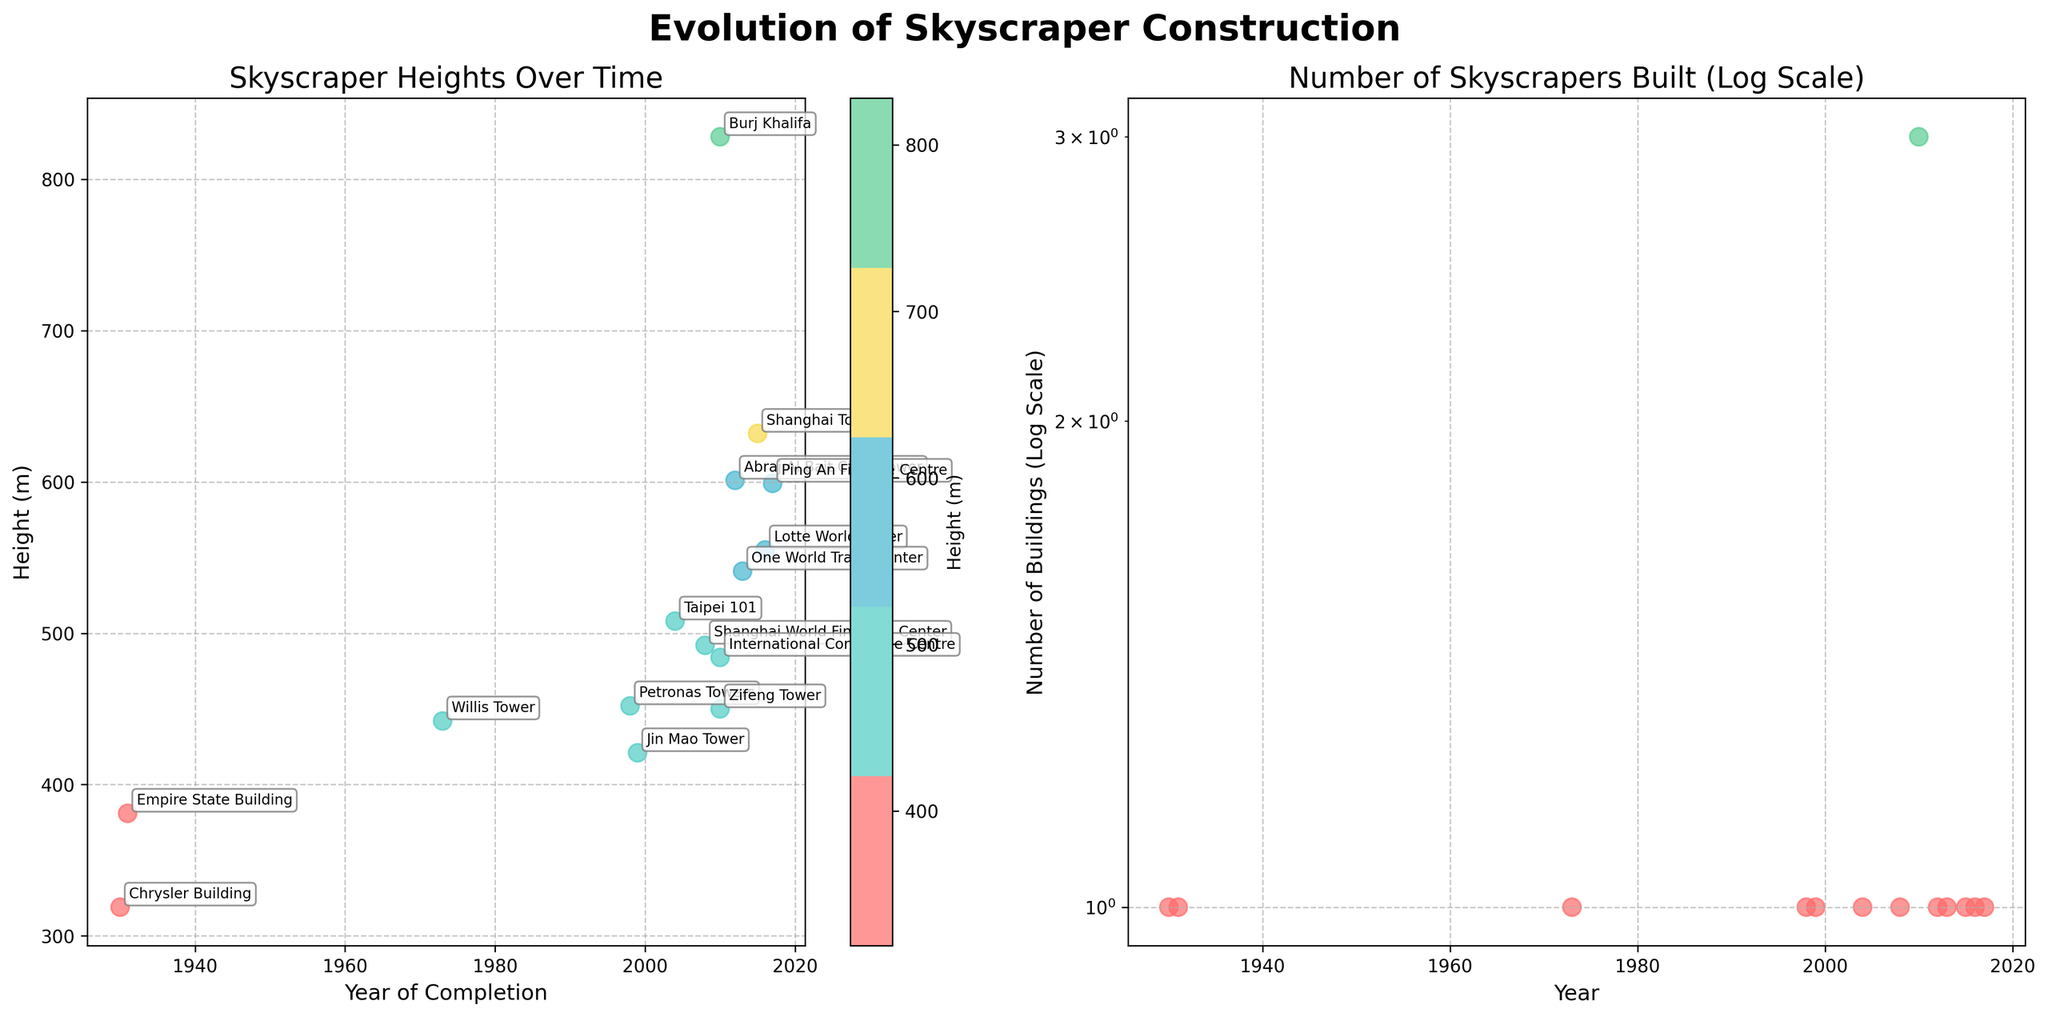What is the title of the figure? The title of the figure is usually found at the top center. In this case, it is "Evolution of Skyscraper Construction".
Answer: Evolution of Skyscraper Construction What is the x-axis label for the plot on the left? The x-axis label for the plot on the left can be found below the x-axis. Here, the label is "Year of Completion".
Answer: Year of Completion How many buildings were completed between 2000 and 2010 inclusive, according to the right subplot? To answer this, we count the number of skyscrapers completed between 2000 and 2010 inclusive. From the data: Taipei 101 (2004), Shanghai World Financial Center (2008), International Commerce Centre (2010), Burj Khalifa (2010), Zifeng Tower (2010) which totals to 5.
Answer: 5 What is the total height of skyscrapers completed in 2010 as shown in the left subplot? To find this, sum the heights of skyscrapers completed in 2010, which are Burj Khalifa (828m), International Commerce Centre (484m), and Zifeng Tower (450m). The total is 828 + 484 + 450 = 1762m.
Answer: 1762m Which building is the tallest according to the left subplot and in which year was it completed? The tallest building can be identified by looking at the highest point on the y-axis. The tallest from the list is Burj Khalifa at 828 meters, completed in 2010.
Answer: Burj Khalifa, 2010 Is there a year where more than one skyscraper was completed according to the right subplot? By inspecting the scatter plot for overlapping points on the x-axis, we see that 2010 has multiple points, indicating more than one skyscraper was completed in that year.
Answer: Yes, 2010 Which year has the highest number of skyscraper completions on a logarithmic scale, as illustrated on the right subplot? To find this, look for the data point with the highest value on the y-axis of the right subplot. The year 2010 has the highest number of completions.
Answer: 2010 What patterns/trends can you observe about the height of skyscrapers over the years based on the left subplot? Observing the left subplot's scatter points, we notice that the heights of skyscrapers have generally increased over the years, with newer buildings exceeding the heights of older ones. Post-2000, the heights have seen a significant rise.
Answer: Increasing height trend over years Based on the right subplot, has the number of skyscrapers built each year significantly increased or stayed relatively stable over time? From the right subplot, observing the scatter points on a logarithmic scale, the number of skyscrapers built each year shows an increasing trend, with more frequent completions in recent years compared to earlier periods.
Answer: Increased 